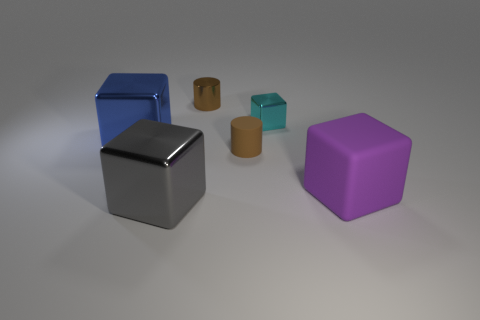There is a big thing right of the small cylinder behind the big blue metallic block that is on the left side of the tiny cube; what color is it?
Your answer should be compact. Purple. Is there a blue thing of the same shape as the gray thing?
Offer a terse response. Yes. How many gray metallic blocks are there?
Provide a short and direct response. 1. What shape is the gray object?
Offer a very short reply. Cube. What number of blue balls have the same size as the cyan object?
Your response must be concise. 0. Is the shape of the cyan object the same as the big blue object?
Make the answer very short. Yes. There is a tiny object that is in front of the large metal cube left of the big gray cube; what color is it?
Provide a succinct answer. Brown. There is a block that is both to the left of the small cyan metal cube and in front of the tiny brown rubber cylinder; what size is it?
Provide a short and direct response. Large. Is there any other thing of the same color as the metallic cylinder?
Make the answer very short. Yes. The big blue thing that is made of the same material as the large gray cube is what shape?
Provide a succinct answer. Cube. 